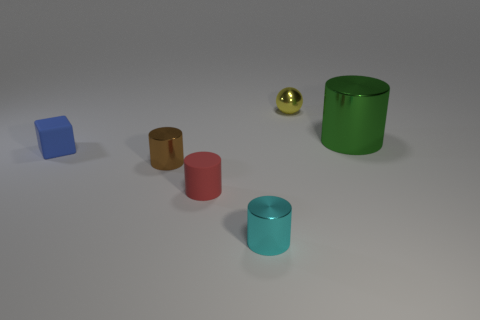What is the shape of the tiny thing behind the big green metallic object?
Offer a terse response. Sphere. There is a shiny object on the left side of the metal cylinder in front of the small brown metal thing; are there any green cylinders on the left side of it?
Your response must be concise. No. What material is the tiny cyan object that is the same shape as the big green object?
Give a very brief answer. Metal. How many blocks are yellow metallic things or cyan metallic objects?
Keep it short and to the point. 0. Is the size of the metallic object that is left of the cyan shiny cylinder the same as the metal thing that is behind the big thing?
Your answer should be compact. Yes. The thing behind the metal thing that is on the right side of the tiny yellow shiny sphere is made of what material?
Offer a terse response. Metal. Is the number of small rubber objects in front of the tiny red cylinder less than the number of large cyan matte cubes?
Offer a very short reply. No. There is a yellow object that is the same material as the brown thing; what shape is it?
Your response must be concise. Sphere. What number of other things are there of the same shape as the yellow metal thing?
Provide a succinct answer. 0. What number of yellow things are tiny metal spheres or cylinders?
Keep it short and to the point. 1. 